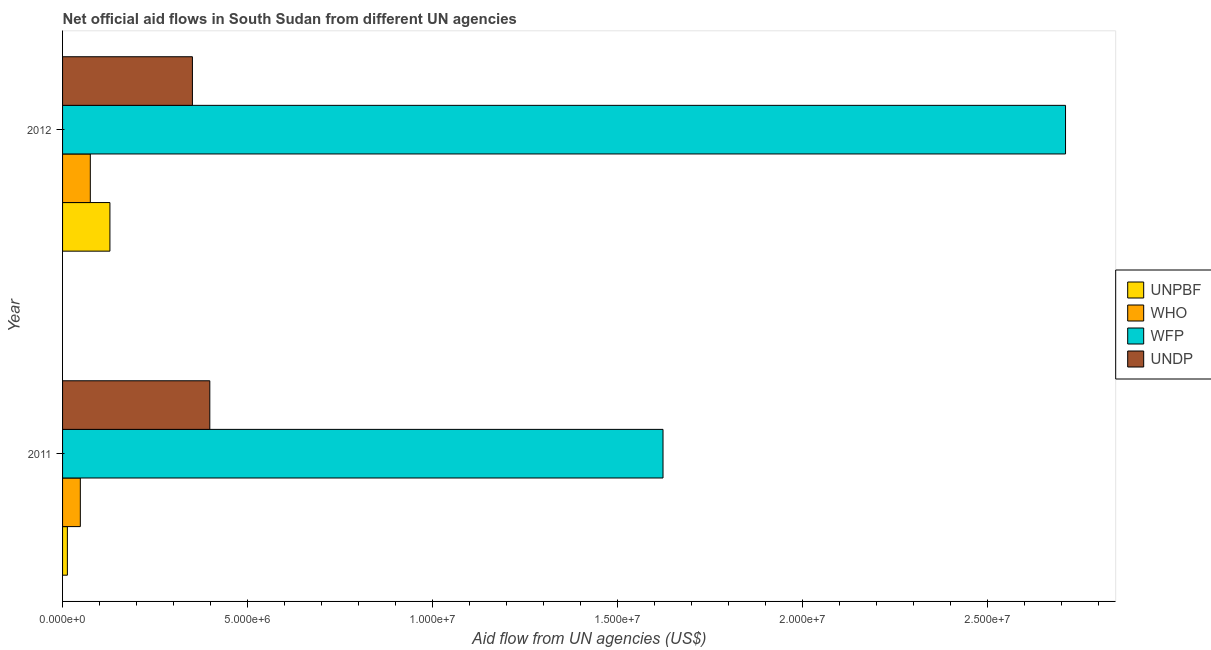How many different coloured bars are there?
Keep it short and to the point. 4. How many groups of bars are there?
Keep it short and to the point. 2. Are the number of bars per tick equal to the number of legend labels?
Your answer should be very brief. Yes. Are the number of bars on each tick of the Y-axis equal?
Provide a short and direct response. Yes. How many bars are there on the 2nd tick from the bottom?
Give a very brief answer. 4. What is the label of the 2nd group of bars from the top?
Ensure brevity in your answer.  2011. In how many cases, is the number of bars for a given year not equal to the number of legend labels?
Give a very brief answer. 0. What is the amount of aid given by unpbf in 2011?
Keep it short and to the point. 1.30e+05. Across all years, what is the maximum amount of aid given by wfp?
Your answer should be compact. 2.71e+07. Across all years, what is the minimum amount of aid given by who?
Your answer should be compact. 4.80e+05. In which year was the amount of aid given by unpbf minimum?
Make the answer very short. 2011. What is the total amount of aid given by unpbf in the graph?
Provide a short and direct response. 1.41e+06. What is the difference between the amount of aid given by who in 2011 and that in 2012?
Give a very brief answer. -2.70e+05. What is the difference between the amount of aid given by who in 2012 and the amount of aid given by unpbf in 2011?
Your answer should be very brief. 6.20e+05. What is the average amount of aid given by undp per year?
Ensure brevity in your answer.  3.74e+06. In the year 2012, what is the difference between the amount of aid given by undp and amount of aid given by who?
Offer a terse response. 2.76e+06. What is the ratio of the amount of aid given by undp in 2011 to that in 2012?
Your response must be concise. 1.13. Is the amount of aid given by wfp in 2011 less than that in 2012?
Your response must be concise. Yes. Is the difference between the amount of aid given by who in 2011 and 2012 greater than the difference between the amount of aid given by undp in 2011 and 2012?
Ensure brevity in your answer.  No. What does the 2nd bar from the top in 2011 represents?
Keep it short and to the point. WFP. What does the 4th bar from the bottom in 2012 represents?
Make the answer very short. UNDP. Is it the case that in every year, the sum of the amount of aid given by unpbf and amount of aid given by who is greater than the amount of aid given by wfp?
Your answer should be very brief. No. Are all the bars in the graph horizontal?
Keep it short and to the point. Yes. What is the difference between two consecutive major ticks on the X-axis?
Ensure brevity in your answer.  5.00e+06. Does the graph contain any zero values?
Keep it short and to the point. No. Does the graph contain grids?
Make the answer very short. No. Where does the legend appear in the graph?
Provide a succinct answer. Center right. How are the legend labels stacked?
Your response must be concise. Vertical. What is the title of the graph?
Your answer should be very brief. Net official aid flows in South Sudan from different UN agencies. What is the label or title of the X-axis?
Give a very brief answer. Aid flow from UN agencies (US$). What is the label or title of the Y-axis?
Offer a terse response. Year. What is the Aid flow from UN agencies (US$) in WFP in 2011?
Offer a very short reply. 1.62e+07. What is the Aid flow from UN agencies (US$) of UNDP in 2011?
Keep it short and to the point. 3.98e+06. What is the Aid flow from UN agencies (US$) in UNPBF in 2012?
Provide a short and direct response. 1.28e+06. What is the Aid flow from UN agencies (US$) of WHO in 2012?
Keep it short and to the point. 7.50e+05. What is the Aid flow from UN agencies (US$) of WFP in 2012?
Your answer should be very brief. 2.71e+07. What is the Aid flow from UN agencies (US$) of UNDP in 2012?
Make the answer very short. 3.51e+06. Across all years, what is the maximum Aid flow from UN agencies (US$) in UNPBF?
Provide a succinct answer. 1.28e+06. Across all years, what is the maximum Aid flow from UN agencies (US$) of WHO?
Keep it short and to the point. 7.50e+05. Across all years, what is the maximum Aid flow from UN agencies (US$) of WFP?
Offer a very short reply. 2.71e+07. Across all years, what is the maximum Aid flow from UN agencies (US$) of UNDP?
Provide a succinct answer. 3.98e+06. Across all years, what is the minimum Aid flow from UN agencies (US$) of WFP?
Provide a succinct answer. 1.62e+07. Across all years, what is the minimum Aid flow from UN agencies (US$) in UNDP?
Provide a short and direct response. 3.51e+06. What is the total Aid flow from UN agencies (US$) of UNPBF in the graph?
Your answer should be compact. 1.41e+06. What is the total Aid flow from UN agencies (US$) in WHO in the graph?
Your response must be concise. 1.23e+06. What is the total Aid flow from UN agencies (US$) in WFP in the graph?
Make the answer very short. 4.33e+07. What is the total Aid flow from UN agencies (US$) of UNDP in the graph?
Give a very brief answer. 7.49e+06. What is the difference between the Aid flow from UN agencies (US$) of UNPBF in 2011 and that in 2012?
Provide a succinct answer. -1.15e+06. What is the difference between the Aid flow from UN agencies (US$) of WHO in 2011 and that in 2012?
Your answer should be very brief. -2.70e+05. What is the difference between the Aid flow from UN agencies (US$) of WFP in 2011 and that in 2012?
Your response must be concise. -1.09e+07. What is the difference between the Aid flow from UN agencies (US$) in UNDP in 2011 and that in 2012?
Make the answer very short. 4.70e+05. What is the difference between the Aid flow from UN agencies (US$) in UNPBF in 2011 and the Aid flow from UN agencies (US$) in WHO in 2012?
Provide a succinct answer. -6.20e+05. What is the difference between the Aid flow from UN agencies (US$) in UNPBF in 2011 and the Aid flow from UN agencies (US$) in WFP in 2012?
Offer a very short reply. -2.70e+07. What is the difference between the Aid flow from UN agencies (US$) in UNPBF in 2011 and the Aid flow from UN agencies (US$) in UNDP in 2012?
Give a very brief answer. -3.38e+06. What is the difference between the Aid flow from UN agencies (US$) in WHO in 2011 and the Aid flow from UN agencies (US$) in WFP in 2012?
Make the answer very short. -2.66e+07. What is the difference between the Aid flow from UN agencies (US$) in WHO in 2011 and the Aid flow from UN agencies (US$) in UNDP in 2012?
Your answer should be compact. -3.03e+06. What is the difference between the Aid flow from UN agencies (US$) of WFP in 2011 and the Aid flow from UN agencies (US$) of UNDP in 2012?
Your answer should be compact. 1.27e+07. What is the average Aid flow from UN agencies (US$) of UNPBF per year?
Make the answer very short. 7.05e+05. What is the average Aid flow from UN agencies (US$) of WHO per year?
Provide a short and direct response. 6.15e+05. What is the average Aid flow from UN agencies (US$) in WFP per year?
Give a very brief answer. 2.17e+07. What is the average Aid flow from UN agencies (US$) in UNDP per year?
Provide a succinct answer. 3.74e+06. In the year 2011, what is the difference between the Aid flow from UN agencies (US$) in UNPBF and Aid flow from UN agencies (US$) in WHO?
Your response must be concise. -3.50e+05. In the year 2011, what is the difference between the Aid flow from UN agencies (US$) in UNPBF and Aid flow from UN agencies (US$) in WFP?
Provide a succinct answer. -1.61e+07. In the year 2011, what is the difference between the Aid flow from UN agencies (US$) of UNPBF and Aid flow from UN agencies (US$) of UNDP?
Your response must be concise. -3.85e+06. In the year 2011, what is the difference between the Aid flow from UN agencies (US$) of WHO and Aid flow from UN agencies (US$) of WFP?
Provide a succinct answer. -1.58e+07. In the year 2011, what is the difference between the Aid flow from UN agencies (US$) in WHO and Aid flow from UN agencies (US$) in UNDP?
Give a very brief answer. -3.50e+06. In the year 2011, what is the difference between the Aid flow from UN agencies (US$) in WFP and Aid flow from UN agencies (US$) in UNDP?
Keep it short and to the point. 1.22e+07. In the year 2012, what is the difference between the Aid flow from UN agencies (US$) in UNPBF and Aid flow from UN agencies (US$) in WHO?
Give a very brief answer. 5.30e+05. In the year 2012, what is the difference between the Aid flow from UN agencies (US$) of UNPBF and Aid flow from UN agencies (US$) of WFP?
Provide a succinct answer. -2.58e+07. In the year 2012, what is the difference between the Aid flow from UN agencies (US$) in UNPBF and Aid flow from UN agencies (US$) in UNDP?
Provide a succinct answer. -2.23e+06. In the year 2012, what is the difference between the Aid flow from UN agencies (US$) in WHO and Aid flow from UN agencies (US$) in WFP?
Provide a short and direct response. -2.64e+07. In the year 2012, what is the difference between the Aid flow from UN agencies (US$) of WHO and Aid flow from UN agencies (US$) of UNDP?
Your answer should be compact. -2.76e+06. In the year 2012, what is the difference between the Aid flow from UN agencies (US$) of WFP and Aid flow from UN agencies (US$) of UNDP?
Your response must be concise. 2.36e+07. What is the ratio of the Aid flow from UN agencies (US$) in UNPBF in 2011 to that in 2012?
Make the answer very short. 0.1. What is the ratio of the Aid flow from UN agencies (US$) in WHO in 2011 to that in 2012?
Ensure brevity in your answer.  0.64. What is the ratio of the Aid flow from UN agencies (US$) of WFP in 2011 to that in 2012?
Offer a terse response. 0.6. What is the ratio of the Aid flow from UN agencies (US$) in UNDP in 2011 to that in 2012?
Your response must be concise. 1.13. What is the difference between the highest and the second highest Aid flow from UN agencies (US$) in UNPBF?
Your response must be concise. 1.15e+06. What is the difference between the highest and the second highest Aid flow from UN agencies (US$) of WFP?
Your response must be concise. 1.09e+07. What is the difference between the highest and the second highest Aid flow from UN agencies (US$) in UNDP?
Make the answer very short. 4.70e+05. What is the difference between the highest and the lowest Aid flow from UN agencies (US$) in UNPBF?
Your answer should be very brief. 1.15e+06. What is the difference between the highest and the lowest Aid flow from UN agencies (US$) in WFP?
Ensure brevity in your answer.  1.09e+07. 